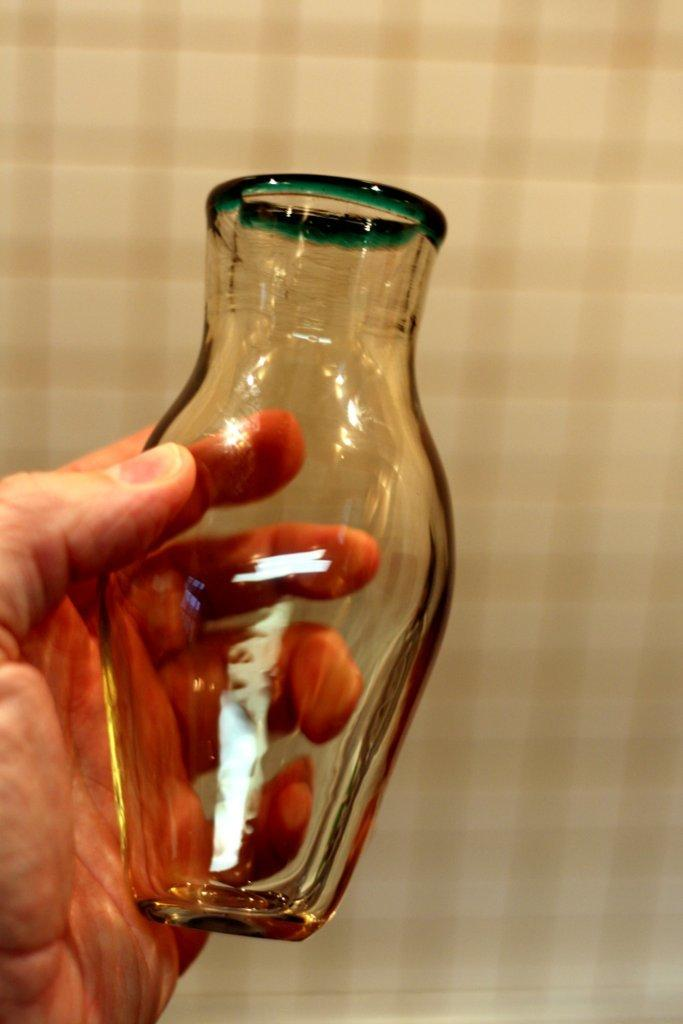Who or what is the main subject in the image? There is a person in the image. What is the person holding in the image? The person is holding a glass jar. What can be seen in the background of the image? There is a wall in the background of the image. What type of waves can be seen crashing against the shore in the image? There are no waves or shore present in the image; it features a person holding a glass jar in front of a wall. 